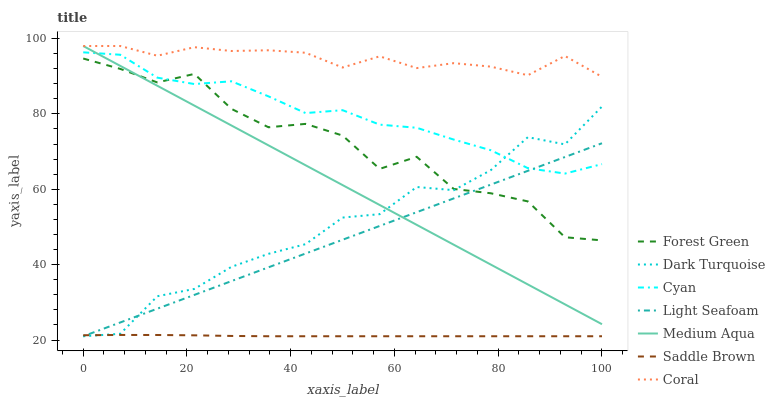Does Saddle Brown have the minimum area under the curve?
Answer yes or no. Yes. Does Coral have the maximum area under the curve?
Answer yes or no. Yes. Does Forest Green have the minimum area under the curve?
Answer yes or no. No. Does Forest Green have the maximum area under the curve?
Answer yes or no. No. Is Light Seafoam the smoothest?
Answer yes or no. Yes. Is Forest Green the roughest?
Answer yes or no. Yes. Is Coral the smoothest?
Answer yes or no. No. Is Coral the roughest?
Answer yes or no. No. Does Dark Turquoise have the lowest value?
Answer yes or no. Yes. Does Forest Green have the lowest value?
Answer yes or no. No. Does Medium Aqua have the highest value?
Answer yes or no. Yes. Does Forest Green have the highest value?
Answer yes or no. No. Is Saddle Brown less than Cyan?
Answer yes or no. Yes. Is Coral greater than Forest Green?
Answer yes or no. Yes. Does Light Seafoam intersect Cyan?
Answer yes or no. Yes. Is Light Seafoam less than Cyan?
Answer yes or no. No. Is Light Seafoam greater than Cyan?
Answer yes or no. No. Does Saddle Brown intersect Cyan?
Answer yes or no. No. 